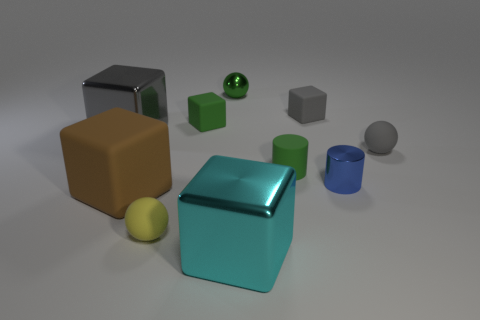Do the big brown matte object and the big metal thing that is in front of the tiny blue metallic thing have the same shape?
Your response must be concise. Yes. Are there any tiny metallic cylinders right of the blue object?
Your answer should be compact. No. What is the material of the small block that is the same color as the small rubber cylinder?
Offer a very short reply. Rubber. What number of cylinders are large green metal objects or big things?
Your response must be concise. 0. Does the yellow rubber object have the same shape as the big brown object?
Ensure brevity in your answer.  No. There is a matte block on the right side of the tiny metallic ball; how big is it?
Keep it short and to the point. Small. Are there any rubber cylinders that have the same color as the large matte thing?
Make the answer very short. No. Does the gray block that is left of the yellow sphere have the same size as the brown rubber block?
Provide a short and direct response. Yes. What color is the metal ball?
Keep it short and to the point. Green. What is the color of the big thing that is right of the shiny thing behind the small green block?
Give a very brief answer. Cyan. 